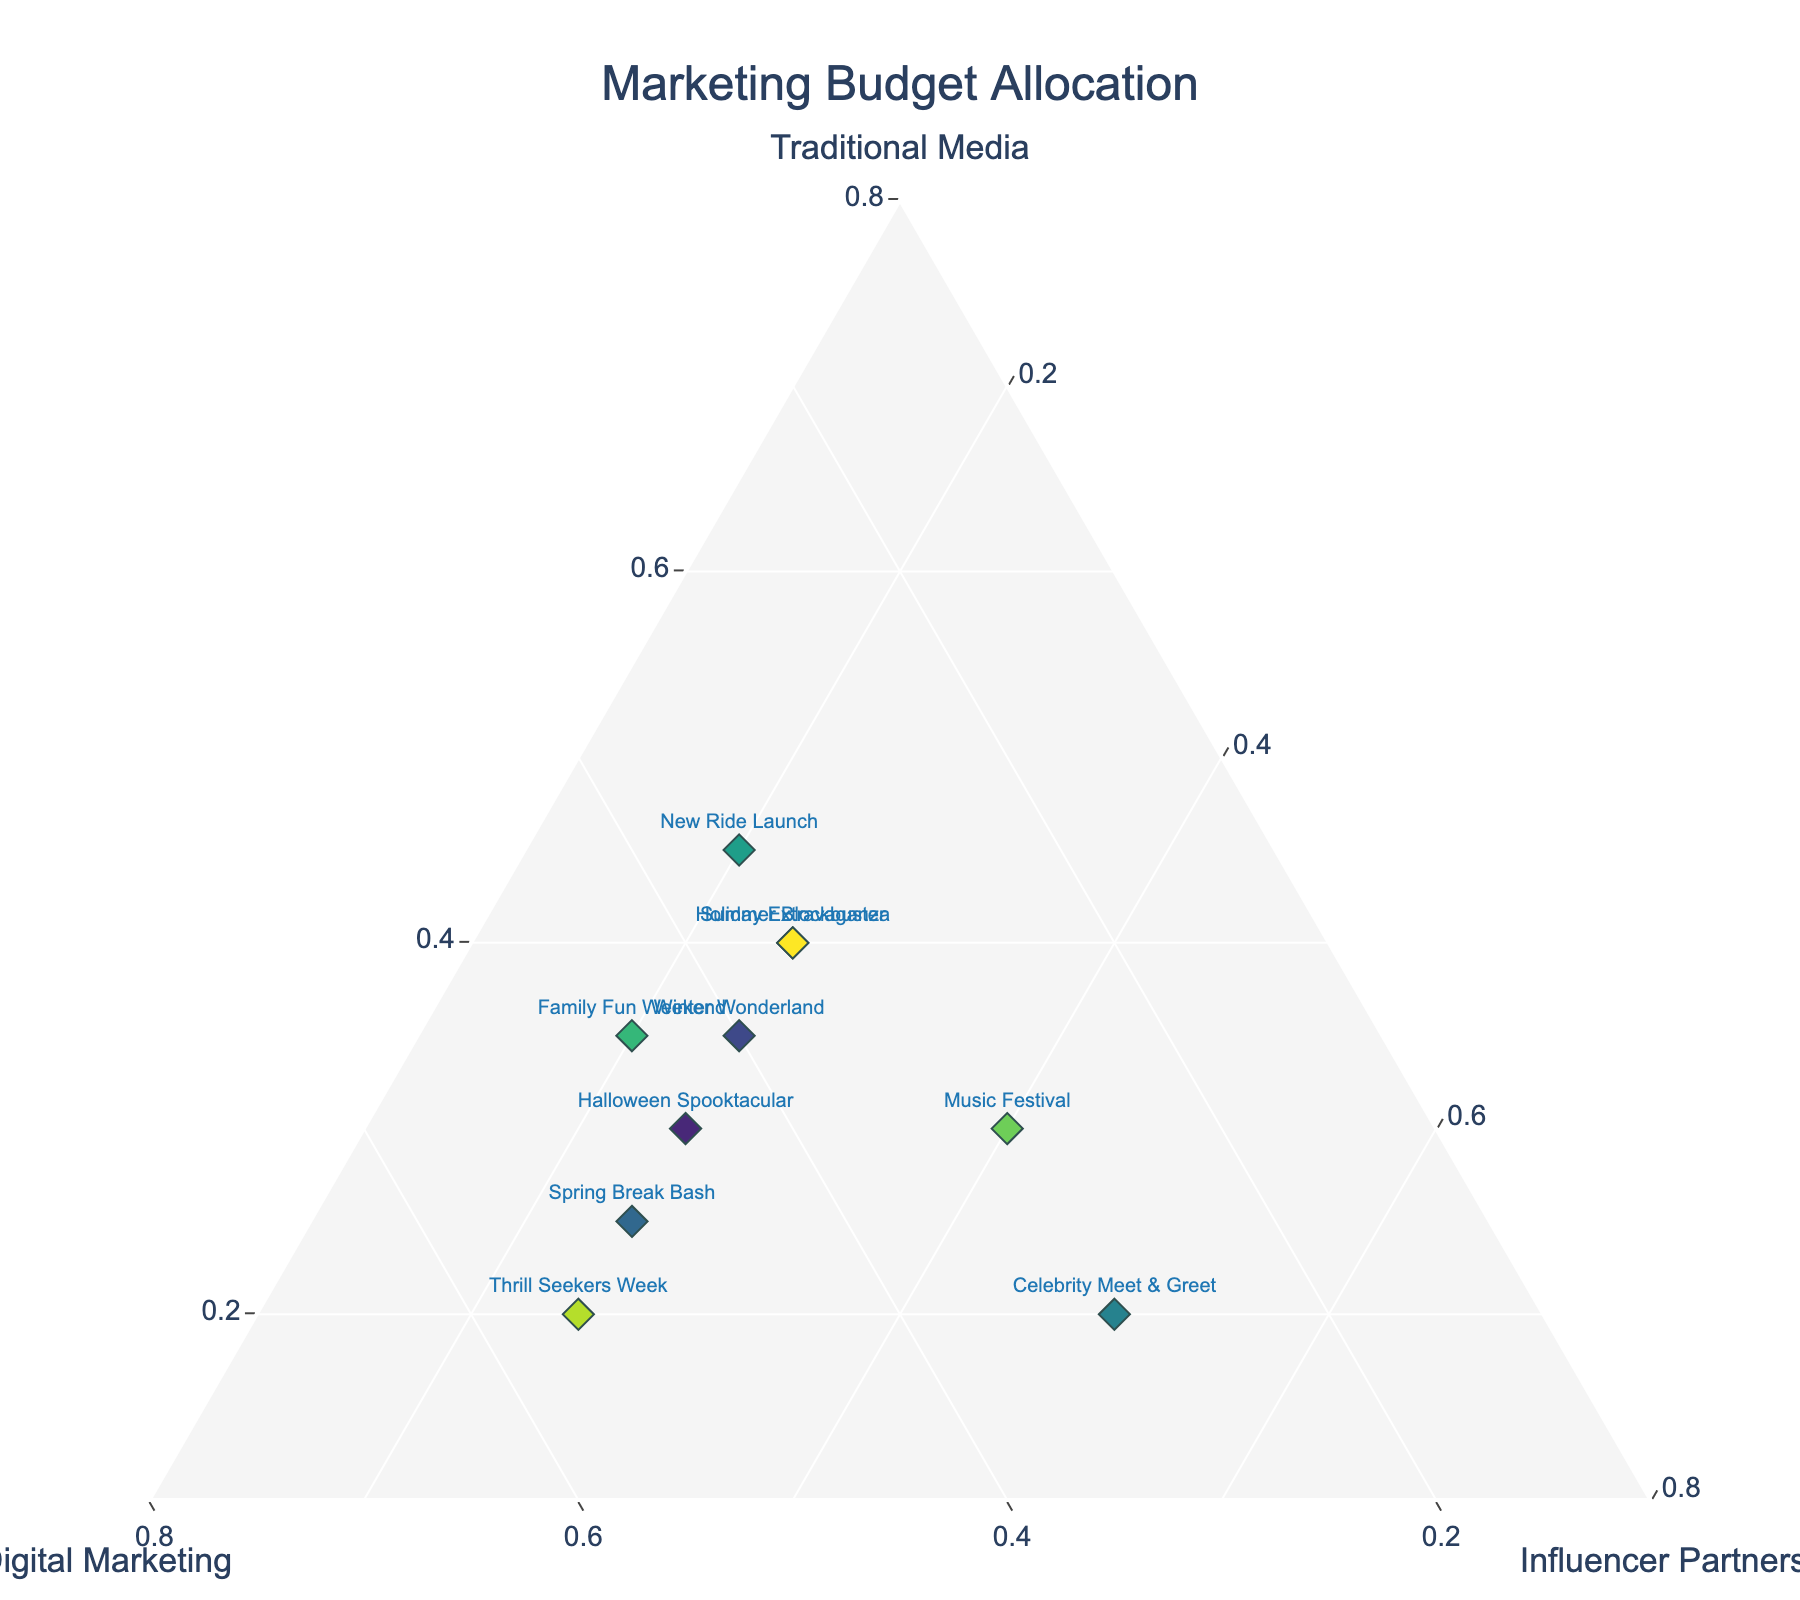What's the title of the plot? The title is generally located at the top of the plot and typically provides a summary of what the plot represents. In this case, we are looking for the name given to this specific plot.
Answer: Marketing Budget Allocation What are the three marketing categories represented on the axes of the plot? Each axis of a ternary plot represents a component or category. By examining the titles given to each axis, one can identify these categories.
Answer: Traditional Media, Digital Marketing, Influencer Partnerships Which event allocated the highest percentage to Influencer Partnerships? In a ternary plot, the higher value for a specific category directs the point closer to the corresponding axis. By observing which point is closest to the Influencer Partnerships axis and reading its label, we can determine this.
Answer: Celebrity Meet & Greet Did any event allocate the same percentage to all three categories? In a ternary plot, an equal allocation to all categories would place the point in the center of the plot. By observing the plot and checking for such points, it is determined if any point meets this criterion.
Answer: No Which event has the highest allocation to Digital Marketing? Points closest to the Digital Marketing axis represent the highest values for that category. By inspecting which point is nearest to this axis, the corresponding event can be found.
Answer: Thrill Seekers Week What is the relationship between Traditional Media and Digital Marketing for the Winter Wonderland event? By locating the Winter Wonderland point, one can compare the values, checking if one is greater than, less than, or equal to the other by reading the corresponding axis positions.
Answer: Digital Marketing is greater than Traditional Media How many events allocated at least 40% to Traditional Media? By checking each point, if its distance from the Traditional Media axis suggests at least 40%, this is counted and totaled.
Answer: Four What is the average percentage allocation to Influencer Partnerships across all events? Sum the Influencer Partnerships percentages for all events and divide by the total number of events to get the average.
Answer: 28% Does any event show an equal allocation between Traditional Media and Digital Marketing? Find the points on the plot where the distances from the Traditional Media and Digital Marketing axes are the same, and check if such events exist.
Answer: No What is the difference in Digital Marketing allocation between Halloween Spooktacular and Family Fun Weekend? Subtract the Digital Marketing value of Halloween Spooktacular from that of Family Fun Weekend by referring to the values given for these events.
Answer: 0 